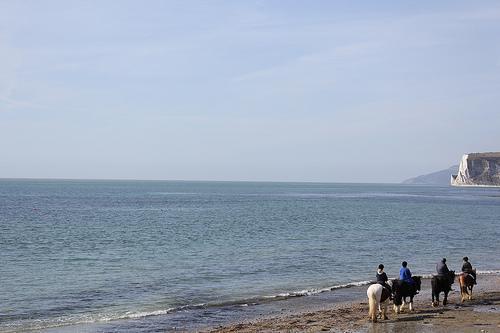How many people in the photo?
Give a very brief answer. 4. 